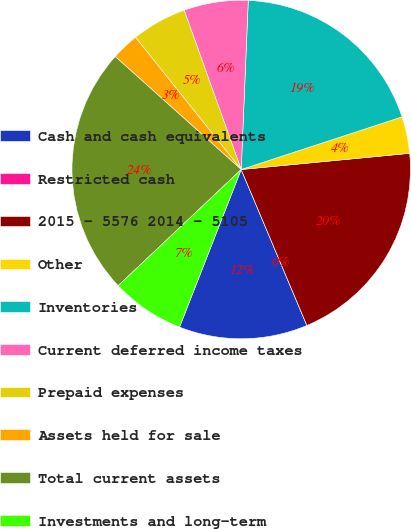Convert chart. <chart><loc_0><loc_0><loc_500><loc_500><pie_chart><fcel>Cash and cash equivalents<fcel>Restricted cash<fcel>2015 - 5576 2014 - 5105<fcel>Other<fcel>Inventories<fcel>Current deferred income taxes<fcel>Prepaid expenses<fcel>Assets held for sale<fcel>Total current assets<fcel>Investments and long-term<nl><fcel>12.28%<fcel>0.0%<fcel>20.18%<fcel>3.51%<fcel>19.3%<fcel>6.14%<fcel>5.26%<fcel>2.63%<fcel>23.68%<fcel>7.02%<nl></chart> 